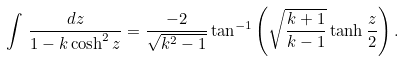Convert formula to latex. <formula><loc_0><loc_0><loc_500><loc_500>\int \, \frac { d z } { 1 - k \cosh ^ { 2 } z } = \frac { - 2 } { \sqrt { k ^ { 2 } - 1 } } \tan ^ { - 1 } \left ( \sqrt { \frac { k + 1 } { k - 1 } } \tanh \frac { z } { 2 } \right ) .</formula> 